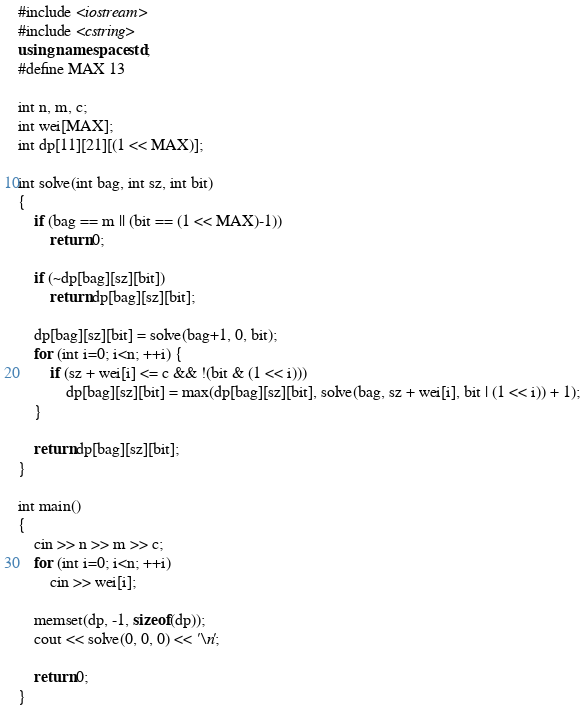<code> <loc_0><loc_0><loc_500><loc_500><_C++_>#include <iostream>
#include <cstring>
using namespace std;
#define MAX 13

int n, m, c;
int wei[MAX];
int dp[11][21][(1 << MAX)];

int solve(int bag, int sz, int bit)
{
	if (bag == m || (bit == (1 << MAX)-1))
		return 0;

	if (~dp[bag][sz][bit])
		return dp[bag][sz][bit];

	dp[bag][sz][bit] = solve(bag+1, 0, bit);
	for (int i=0; i<n; ++i) {
		if (sz + wei[i] <= c && !(bit & (1 << i)))
			dp[bag][sz][bit] = max(dp[bag][sz][bit], solve(bag, sz + wei[i], bit | (1 << i)) + 1);
	}

	return dp[bag][sz][bit];
}

int main()
{
	cin >> n >> m >> c;
	for (int i=0; i<n; ++i)
		cin >> wei[i];

	memset(dp, -1, sizeof(dp));
	cout << solve(0, 0, 0) << '\n';

	return 0;
}
</code> 